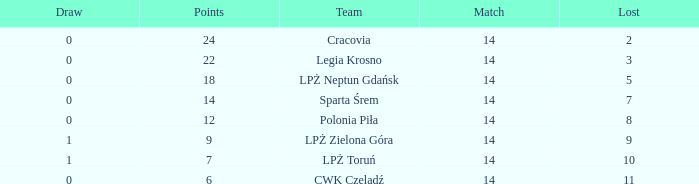What is the sum for the match with a draw less than 0? None. 